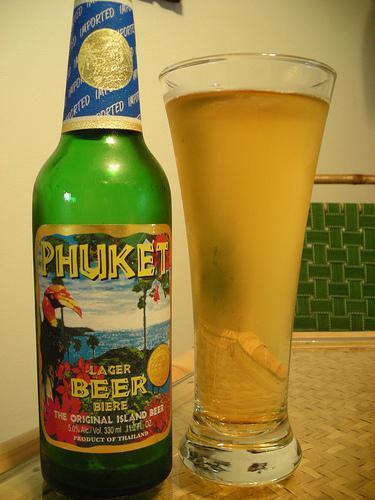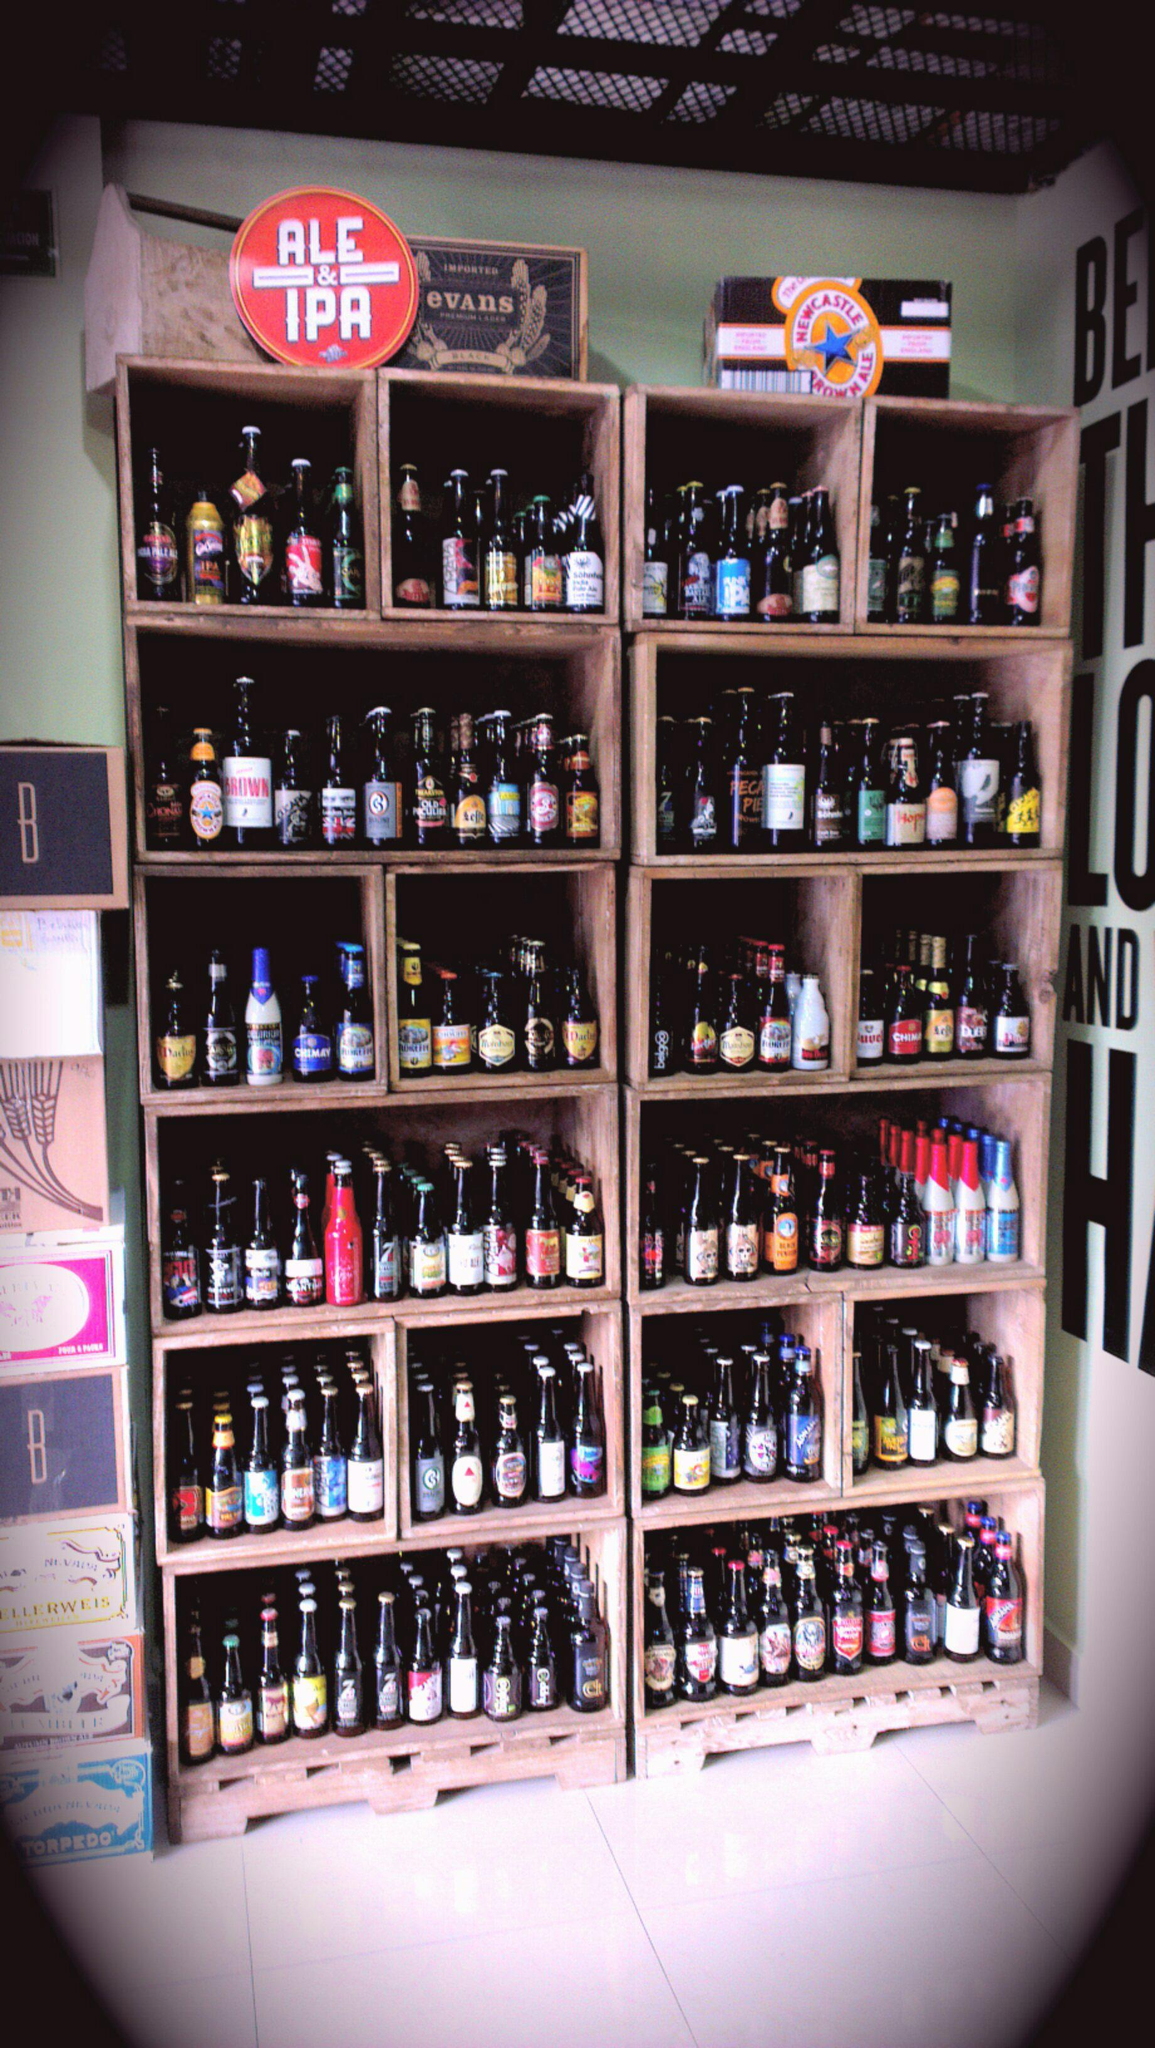The first image is the image on the left, the second image is the image on the right. Considering the images on both sides, is "In at least one image there are at least two sets of shelves holding at least three levels of beer bottles." valid? Answer yes or no. Yes. 